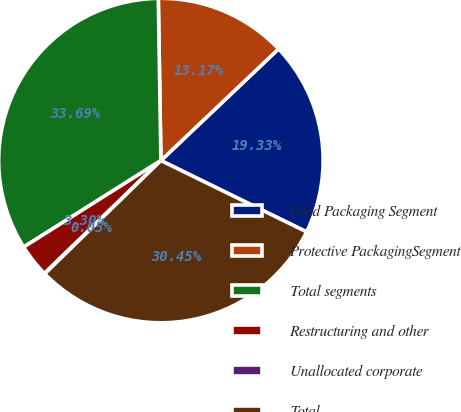Convert chart. <chart><loc_0><loc_0><loc_500><loc_500><pie_chart><fcel>Food Packaging Segment<fcel>Protective PackagingSegment<fcel>Total segments<fcel>Restructuring and other<fcel>Unallocated corporate<fcel>Total<nl><fcel>19.33%<fcel>13.17%<fcel>33.69%<fcel>3.3%<fcel>0.05%<fcel>30.45%<nl></chart> 